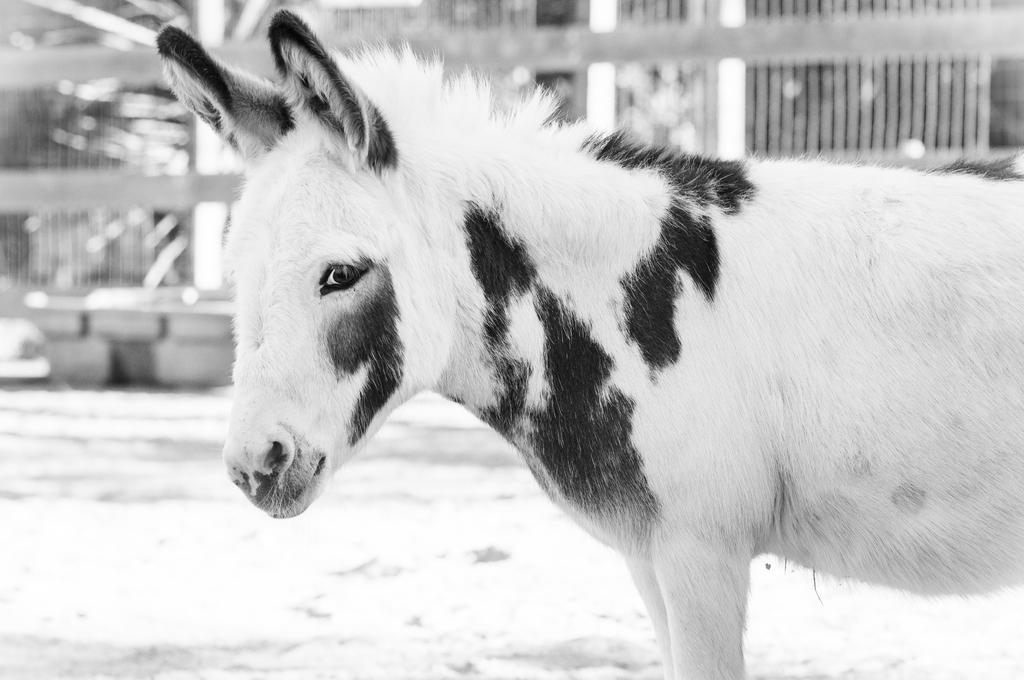Please provide a concise description of this image. This is a black and white pic. We can see an animal. In the background the image is blur but we can see plants and other objects. 